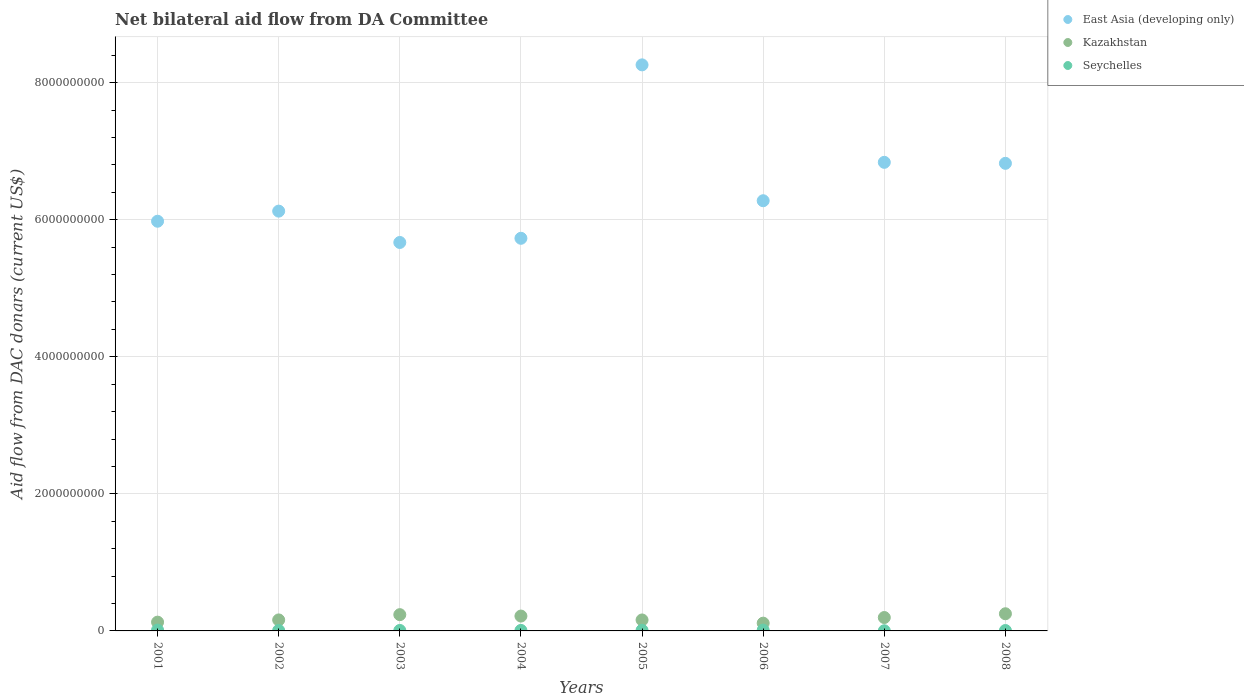How many different coloured dotlines are there?
Your answer should be very brief. 3. Is the number of dotlines equal to the number of legend labels?
Your answer should be compact. Yes. What is the aid flow in in Kazakhstan in 2004?
Offer a terse response. 2.17e+08. Across all years, what is the maximum aid flow in in Kazakhstan?
Offer a very short reply. 2.50e+08. Across all years, what is the minimum aid flow in in Seychelles?
Give a very brief answer. 2.29e+06. What is the total aid flow in in Seychelles in the graph?
Your answer should be compact. 6.18e+07. What is the difference between the aid flow in in Kazakhstan in 2002 and that in 2004?
Provide a short and direct response. -5.61e+07. What is the difference between the aid flow in in Seychelles in 2006 and the aid flow in in Kazakhstan in 2004?
Provide a succinct answer. -2.05e+08. What is the average aid flow in in East Asia (developing only) per year?
Ensure brevity in your answer.  6.46e+09. In the year 2006, what is the difference between the aid flow in in Seychelles and aid flow in in East Asia (developing only)?
Make the answer very short. -6.27e+09. In how many years, is the aid flow in in Kazakhstan greater than 6000000000 US$?
Make the answer very short. 0. What is the ratio of the aid flow in in Seychelles in 2001 to that in 2002?
Offer a very short reply. 1.82. Is the aid flow in in Seychelles in 2007 less than that in 2008?
Ensure brevity in your answer.  Yes. What is the difference between the highest and the second highest aid flow in in Kazakhstan?
Provide a short and direct response. 1.31e+07. What is the difference between the highest and the lowest aid flow in in Seychelles?
Provide a succinct answer. 9.79e+06. In how many years, is the aid flow in in East Asia (developing only) greater than the average aid flow in in East Asia (developing only) taken over all years?
Provide a short and direct response. 3. Is the sum of the aid flow in in Seychelles in 2005 and 2008 greater than the maximum aid flow in in Kazakhstan across all years?
Offer a terse response. No. Is it the case that in every year, the sum of the aid flow in in East Asia (developing only) and aid flow in in Seychelles  is greater than the aid flow in in Kazakhstan?
Your response must be concise. Yes. Does the aid flow in in Kazakhstan monotonically increase over the years?
Ensure brevity in your answer.  No. How many years are there in the graph?
Keep it short and to the point. 8. Are the values on the major ticks of Y-axis written in scientific E-notation?
Provide a short and direct response. No. How are the legend labels stacked?
Provide a short and direct response. Vertical. What is the title of the graph?
Keep it short and to the point. Net bilateral aid flow from DA Committee. Does "Korea (Republic)" appear as one of the legend labels in the graph?
Ensure brevity in your answer.  No. What is the label or title of the Y-axis?
Make the answer very short. Aid flow from DAC donars (current US$). What is the Aid flow from DAC donars (current US$) of East Asia (developing only) in 2001?
Make the answer very short. 5.98e+09. What is the Aid flow from DAC donars (current US$) in Kazakhstan in 2001?
Your answer should be compact. 1.28e+08. What is the Aid flow from DAC donars (current US$) in Seychelles in 2001?
Provide a succinct answer. 1.21e+07. What is the Aid flow from DAC donars (current US$) of East Asia (developing only) in 2002?
Provide a succinct answer. 6.12e+09. What is the Aid flow from DAC donars (current US$) of Kazakhstan in 2002?
Your answer should be compact. 1.61e+08. What is the Aid flow from DAC donars (current US$) of Seychelles in 2002?
Offer a very short reply. 6.64e+06. What is the Aid flow from DAC donars (current US$) of East Asia (developing only) in 2003?
Make the answer very short. 5.67e+09. What is the Aid flow from DAC donars (current US$) of Kazakhstan in 2003?
Ensure brevity in your answer.  2.37e+08. What is the Aid flow from DAC donars (current US$) of Seychelles in 2003?
Your answer should be very brief. 6.68e+06. What is the Aid flow from DAC donars (current US$) of East Asia (developing only) in 2004?
Keep it short and to the point. 5.73e+09. What is the Aid flow from DAC donars (current US$) in Kazakhstan in 2004?
Offer a terse response. 2.17e+08. What is the Aid flow from DAC donars (current US$) of Seychelles in 2004?
Give a very brief answer. 7.43e+06. What is the Aid flow from DAC donars (current US$) in East Asia (developing only) in 2005?
Provide a succinct answer. 8.26e+09. What is the Aid flow from DAC donars (current US$) in Kazakhstan in 2005?
Offer a very short reply. 1.60e+08. What is the Aid flow from DAC donars (current US$) of Seychelles in 2005?
Provide a succinct answer. 9.34e+06. What is the Aid flow from DAC donars (current US$) in East Asia (developing only) in 2006?
Offer a terse response. 6.28e+09. What is the Aid flow from DAC donars (current US$) of Kazakhstan in 2006?
Offer a very short reply. 1.13e+08. What is the Aid flow from DAC donars (current US$) of Seychelles in 2006?
Offer a very short reply. 1.16e+07. What is the Aid flow from DAC donars (current US$) of East Asia (developing only) in 2007?
Your answer should be compact. 6.84e+09. What is the Aid flow from DAC donars (current US$) in Kazakhstan in 2007?
Offer a terse response. 1.95e+08. What is the Aid flow from DAC donars (current US$) in Seychelles in 2007?
Offer a terse response. 2.29e+06. What is the Aid flow from DAC donars (current US$) of East Asia (developing only) in 2008?
Your response must be concise. 6.82e+09. What is the Aid flow from DAC donars (current US$) in Kazakhstan in 2008?
Give a very brief answer. 2.50e+08. What is the Aid flow from DAC donars (current US$) in Seychelles in 2008?
Make the answer very short. 5.77e+06. Across all years, what is the maximum Aid flow from DAC donars (current US$) in East Asia (developing only)?
Keep it short and to the point. 8.26e+09. Across all years, what is the maximum Aid flow from DAC donars (current US$) of Kazakhstan?
Your answer should be compact. 2.50e+08. Across all years, what is the maximum Aid flow from DAC donars (current US$) in Seychelles?
Your answer should be very brief. 1.21e+07. Across all years, what is the minimum Aid flow from DAC donars (current US$) in East Asia (developing only)?
Your answer should be very brief. 5.67e+09. Across all years, what is the minimum Aid flow from DAC donars (current US$) of Kazakhstan?
Give a very brief answer. 1.13e+08. Across all years, what is the minimum Aid flow from DAC donars (current US$) of Seychelles?
Make the answer very short. 2.29e+06. What is the total Aid flow from DAC donars (current US$) of East Asia (developing only) in the graph?
Give a very brief answer. 5.17e+1. What is the total Aid flow from DAC donars (current US$) of Kazakhstan in the graph?
Provide a succinct answer. 1.46e+09. What is the total Aid flow from DAC donars (current US$) of Seychelles in the graph?
Your answer should be compact. 6.18e+07. What is the difference between the Aid flow from DAC donars (current US$) of East Asia (developing only) in 2001 and that in 2002?
Provide a succinct answer. -1.47e+08. What is the difference between the Aid flow from DAC donars (current US$) of Kazakhstan in 2001 and that in 2002?
Your answer should be very brief. -3.24e+07. What is the difference between the Aid flow from DAC donars (current US$) of Seychelles in 2001 and that in 2002?
Provide a short and direct response. 5.44e+06. What is the difference between the Aid flow from DAC donars (current US$) of East Asia (developing only) in 2001 and that in 2003?
Offer a terse response. 3.10e+08. What is the difference between the Aid flow from DAC donars (current US$) in Kazakhstan in 2001 and that in 2003?
Your answer should be compact. -1.09e+08. What is the difference between the Aid flow from DAC donars (current US$) of Seychelles in 2001 and that in 2003?
Provide a short and direct response. 5.40e+06. What is the difference between the Aid flow from DAC donars (current US$) of East Asia (developing only) in 2001 and that in 2004?
Give a very brief answer. 2.49e+08. What is the difference between the Aid flow from DAC donars (current US$) of Kazakhstan in 2001 and that in 2004?
Your answer should be compact. -8.86e+07. What is the difference between the Aid flow from DAC donars (current US$) in Seychelles in 2001 and that in 2004?
Provide a short and direct response. 4.65e+06. What is the difference between the Aid flow from DAC donars (current US$) of East Asia (developing only) in 2001 and that in 2005?
Offer a terse response. -2.28e+09. What is the difference between the Aid flow from DAC donars (current US$) of Kazakhstan in 2001 and that in 2005?
Your response must be concise. -3.19e+07. What is the difference between the Aid flow from DAC donars (current US$) of Seychelles in 2001 and that in 2005?
Your answer should be compact. 2.74e+06. What is the difference between the Aid flow from DAC donars (current US$) in East Asia (developing only) in 2001 and that in 2006?
Provide a succinct answer. -2.99e+08. What is the difference between the Aid flow from DAC donars (current US$) in Kazakhstan in 2001 and that in 2006?
Offer a very short reply. 1.48e+07. What is the difference between the Aid flow from DAC donars (current US$) of Seychelles in 2001 and that in 2006?
Ensure brevity in your answer.  5.30e+05. What is the difference between the Aid flow from DAC donars (current US$) in East Asia (developing only) in 2001 and that in 2007?
Offer a very short reply. -8.59e+08. What is the difference between the Aid flow from DAC donars (current US$) of Kazakhstan in 2001 and that in 2007?
Provide a succinct answer. -6.74e+07. What is the difference between the Aid flow from DAC donars (current US$) of Seychelles in 2001 and that in 2007?
Your response must be concise. 9.79e+06. What is the difference between the Aid flow from DAC donars (current US$) of East Asia (developing only) in 2001 and that in 2008?
Provide a short and direct response. -8.45e+08. What is the difference between the Aid flow from DAC donars (current US$) of Kazakhstan in 2001 and that in 2008?
Ensure brevity in your answer.  -1.22e+08. What is the difference between the Aid flow from DAC donars (current US$) in Seychelles in 2001 and that in 2008?
Provide a short and direct response. 6.31e+06. What is the difference between the Aid flow from DAC donars (current US$) of East Asia (developing only) in 2002 and that in 2003?
Your answer should be compact. 4.57e+08. What is the difference between the Aid flow from DAC donars (current US$) of Kazakhstan in 2002 and that in 2003?
Offer a very short reply. -7.68e+07. What is the difference between the Aid flow from DAC donars (current US$) of East Asia (developing only) in 2002 and that in 2004?
Provide a succinct answer. 3.96e+08. What is the difference between the Aid flow from DAC donars (current US$) in Kazakhstan in 2002 and that in 2004?
Your answer should be compact. -5.61e+07. What is the difference between the Aid flow from DAC donars (current US$) in Seychelles in 2002 and that in 2004?
Ensure brevity in your answer.  -7.90e+05. What is the difference between the Aid flow from DAC donars (current US$) in East Asia (developing only) in 2002 and that in 2005?
Provide a succinct answer. -2.13e+09. What is the difference between the Aid flow from DAC donars (current US$) of Kazakhstan in 2002 and that in 2005?
Provide a succinct answer. 5.00e+05. What is the difference between the Aid flow from DAC donars (current US$) of Seychelles in 2002 and that in 2005?
Keep it short and to the point. -2.70e+06. What is the difference between the Aid flow from DAC donars (current US$) of East Asia (developing only) in 2002 and that in 2006?
Offer a very short reply. -1.52e+08. What is the difference between the Aid flow from DAC donars (current US$) in Kazakhstan in 2002 and that in 2006?
Your response must be concise. 4.72e+07. What is the difference between the Aid flow from DAC donars (current US$) of Seychelles in 2002 and that in 2006?
Ensure brevity in your answer.  -4.91e+06. What is the difference between the Aid flow from DAC donars (current US$) in East Asia (developing only) in 2002 and that in 2007?
Your answer should be very brief. -7.12e+08. What is the difference between the Aid flow from DAC donars (current US$) of Kazakhstan in 2002 and that in 2007?
Make the answer very short. -3.49e+07. What is the difference between the Aid flow from DAC donars (current US$) of Seychelles in 2002 and that in 2007?
Ensure brevity in your answer.  4.35e+06. What is the difference between the Aid flow from DAC donars (current US$) of East Asia (developing only) in 2002 and that in 2008?
Ensure brevity in your answer.  -6.97e+08. What is the difference between the Aid flow from DAC donars (current US$) of Kazakhstan in 2002 and that in 2008?
Keep it short and to the point. -8.99e+07. What is the difference between the Aid flow from DAC donars (current US$) of Seychelles in 2002 and that in 2008?
Your response must be concise. 8.70e+05. What is the difference between the Aid flow from DAC donars (current US$) in East Asia (developing only) in 2003 and that in 2004?
Offer a terse response. -6.10e+07. What is the difference between the Aid flow from DAC donars (current US$) in Kazakhstan in 2003 and that in 2004?
Offer a terse response. 2.07e+07. What is the difference between the Aid flow from DAC donars (current US$) of Seychelles in 2003 and that in 2004?
Offer a very short reply. -7.50e+05. What is the difference between the Aid flow from DAC donars (current US$) of East Asia (developing only) in 2003 and that in 2005?
Your answer should be very brief. -2.59e+09. What is the difference between the Aid flow from DAC donars (current US$) of Kazakhstan in 2003 and that in 2005?
Your answer should be very brief. 7.73e+07. What is the difference between the Aid flow from DAC donars (current US$) of Seychelles in 2003 and that in 2005?
Offer a very short reply. -2.66e+06. What is the difference between the Aid flow from DAC donars (current US$) of East Asia (developing only) in 2003 and that in 2006?
Your answer should be compact. -6.09e+08. What is the difference between the Aid flow from DAC donars (current US$) of Kazakhstan in 2003 and that in 2006?
Make the answer very short. 1.24e+08. What is the difference between the Aid flow from DAC donars (current US$) in Seychelles in 2003 and that in 2006?
Provide a short and direct response. -4.87e+06. What is the difference between the Aid flow from DAC donars (current US$) in East Asia (developing only) in 2003 and that in 2007?
Offer a very short reply. -1.17e+09. What is the difference between the Aid flow from DAC donars (current US$) of Kazakhstan in 2003 and that in 2007?
Your answer should be very brief. 4.19e+07. What is the difference between the Aid flow from DAC donars (current US$) in Seychelles in 2003 and that in 2007?
Offer a very short reply. 4.39e+06. What is the difference between the Aid flow from DAC donars (current US$) of East Asia (developing only) in 2003 and that in 2008?
Provide a short and direct response. -1.15e+09. What is the difference between the Aid flow from DAC donars (current US$) in Kazakhstan in 2003 and that in 2008?
Offer a very short reply. -1.31e+07. What is the difference between the Aid flow from DAC donars (current US$) in Seychelles in 2003 and that in 2008?
Provide a succinct answer. 9.10e+05. What is the difference between the Aid flow from DAC donars (current US$) in East Asia (developing only) in 2004 and that in 2005?
Make the answer very short. -2.53e+09. What is the difference between the Aid flow from DAC donars (current US$) in Kazakhstan in 2004 and that in 2005?
Provide a succinct answer. 5.66e+07. What is the difference between the Aid flow from DAC donars (current US$) in Seychelles in 2004 and that in 2005?
Ensure brevity in your answer.  -1.91e+06. What is the difference between the Aid flow from DAC donars (current US$) in East Asia (developing only) in 2004 and that in 2006?
Provide a succinct answer. -5.48e+08. What is the difference between the Aid flow from DAC donars (current US$) of Kazakhstan in 2004 and that in 2006?
Keep it short and to the point. 1.03e+08. What is the difference between the Aid flow from DAC donars (current US$) in Seychelles in 2004 and that in 2006?
Your response must be concise. -4.12e+06. What is the difference between the Aid flow from DAC donars (current US$) in East Asia (developing only) in 2004 and that in 2007?
Your answer should be compact. -1.11e+09. What is the difference between the Aid flow from DAC donars (current US$) of Kazakhstan in 2004 and that in 2007?
Provide a succinct answer. 2.12e+07. What is the difference between the Aid flow from DAC donars (current US$) of Seychelles in 2004 and that in 2007?
Give a very brief answer. 5.14e+06. What is the difference between the Aid flow from DAC donars (current US$) of East Asia (developing only) in 2004 and that in 2008?
Make the answer very short. -1.09e+09. What is the difference between the Aid flow from DAC donars (current US$) in Kazakhstan in 2004 and that in 2008?
Your answer should be very brief. -3.38e+07. What is the difference between the Aid flow from DAC donars (current US$) in Seychelles in 2004 and that in 2008?
Make the answer very short. 1.66e+06. What is the difference between the Aid flow from DAC donars (current US$) of East Asia (developing only) in 2005 and that in 2006?
Your answer should be very brief. 1.98e+09. What is the difference between the Aid flow from DAC donars (current US$) of Kazakhstan in 2005 and that in 2006?
Provide a succinct answer. 4.67e+07. What is the difference between the Aid flow from DAC donars (current US$) of Seychelles in 2005 and that in 2006?
Provide a short and direct response. -2.21e+06. What is the difference between the Aid flow from DAC donars (current US$) in East Asia (developing only) in 2005 and that in 2007?
Offer a terse response. 1.42e+09. What is the difference between the Aid flow from DAC donars (current US$) of Kazakhstan in 2005 and that in 2007?
Give a very brief answer. -3.54e+07. What is the difference between the Aid flow from DAC donars (current US$) in Seychelles in 2005 and that in 2007?
Provide a succinct answer. 7.05e+06. What is the difference between the Aid flow from DAC donars (current US$) of East Asia (developing only) in 2005 and that in 2008?
Provide a short and direct response. 1.44e+09. What is the difference between the Aid flow from DAC donars (current US$) in Kazakhstan in 2005 and that in 2008?
Make the answer very short. -9.04e+07. What is the difference between the Aid flow from DAC donars (current US$) of Seychelles in 2005 and that in 2008?
Your answer should be compact. 3.57e+06. What is the difference between the Aid flow from DAC donars (current US$) of East Asia (developing only) in 2006 and that in 2007?
Offer a terse response. -5.60e+08. What is the difference between the Aid flow from DAC donars (current US$) in Kazakhstan in 2006 and that in 2007?
Give a very brief answer. -8.22e+07. What is the difference between the Aid flow from DAC donars (current US$) in Seychelles in 2006 and that in 2007?
Provide a short and direct response. 9.26e+06. What is the difference between the Aid flow from DAC donars (current US$) in East Asia (developing only) in 2006 and that in 2008?
Provide a short and direct response. -5.46e+08. What is the difference between the Aid flow from DAC donars (current US$) in Kazakhstan in 2006 and that in 2008?
Offer a very short reply. -1.37e+08. What is the difference between the Aid flow from DAC donars (current US$) of Seychelles in 2006 and that in 2008?
Ensure brevity in your answer.  5.78e+06. What is the difference between the Aid flow from DAC donars (current US$) in East Asia (developing only) in 2007 and that in 2008?
Ensure brevity in your answer.  1.45e+07. What is the difference between the Aid flow from DAC donars (current US$) of Kazakhstan in 2007 and that in 2008?
Provide a short and direct response. -5.50e+07. What is the difference between the Aid flow from DAC donars (current US$) of Seychelles in 2007 and that in 2008?
Make the answer very short. -3.48e+06. What is the difference between the Aid flow from DAC donars (current US$) of East Asia (developing only) in 2001 and the Aid flow from DAC donars (current US$) of Kazakhstan in 2002?
Give a very brief answer. 5.82e+09. What is the difference between the Aid flow from DAC donars (current US$) in East Asia (developing only) in 2001 and the Aid flow from DAC donars (current US$) in Seychelles in 2002?
Keep it short and to the point. 5.97e+09. What is the difference between the Aid flow from DAC donars (current US$) in Kazakhstan in 2001 and the Aid flow from DAC donars (current US$) in Seychelles in 2002?
Your answer should be compact. 1.21e+08. What is the difference between the Aid flow from DAC donars (current US$) in East Asia (developing only) in 2001 and the Aid flow from DAC donars (current US$) in Kazakhstan in 2003?
Offer a very short reply. 5.74e+09. What is the difference between the Aid flow from DAC donars (current US$) of East Asia (developing only) in 2001 and the Aid flow from DAC donars (current US$) of Seychelles in 2003?
Provide a succinct answer. 5.97e+09. What is the difference between the Aid flow from DAC donars (current US$) in Kazakhstan in 2001 and the Aid flow from DAC donars (current US$) in Seychelles in 2003?
Offer a terse response. 1.21e+08. What is the difference between the Aid flow from DAC donars (current US$) in East Asia (developing only) in 2001 and the Aid flow from DAC donars (current US$) in Kazakhstan in 2004?
Your answer should be very brief. 5.76e+09. What is the difference between the Aid flow from DAC donars (current US$) of East Asia (developing only) in 2001 and the Aid flow from DAC donars (current US$) of Seychelles in 2004?
Ensure brevity in your answer.  5.97e+09. What is the difference between the Aid flow from DAC donars (current US$) in Kazakhstan in 2001 and the Aid flow from DAC donars (current US$) in Seychelles in 2004?
Your response must be concise. 1.21e+08. What is the difference between the Aid flow from DAC donars (current US$) in East Asia (developing only) in 2001 and the Aid flow from DAC donars (current US$) in Kazakhstan in 2005?
Offer a terse response. 5.82e+09. What is the difference between the Aid flow from DAC donars (current US$) of East Asia (developing only) in 2001 and the Aid flow from DAC donars (current US$) of Seychelles in 2005?
Make the answer very short. 5.97e+09. What is the difference between the Aid flow from DAC donars (current US$) of Kazakhstan in 2001 and the Aid flow from DAC donars (current US$) of Seychelles in 2005?
Your answer should be compact. 1.19e+08. What is the difference between the Aid flow from DAC donars (current US$) in East Asia (developing only) in 2001 and the Aid flow from DAC donars (current US$) in Kazakhstan in 2006?
Make the answer very short. 5.86e+09. What is the difference between the Aid flow from DAC donars (current US$) of East Asia (developing only) in 2001 and the Aid flow from DAC donars (current US$) of Seychelles in 2006?
Offer a terse response. 5.97e+09. What is the difference between the Aid flow from DAC donars (current US$) in Kazakhstan in 2001 and the Aid flow from DAC donars (current US$) in Seychelles in 2006?
Your answer should be very brief. 1.17e+08. What is the difference between the Aid flow from DAC donars (current US$) in East Asia (developing only) in 2001 and the Aid flow from DAC donars (current US$) in Kazakhstan in 2007?
Make the answer very short. 5.78e+09. What is the difference between the Aid flow from DAC donars (current US$) of East Asia (developing only) in 2001 and the Aid flow from DAC donars (current US$) of Seychelles in 2007?
Your answer should be compact. 5.98e+09. What is the difference between the Aid flow from DAC donars (current US$) in Kazakhstan in 2001 and the Aid flow from DAC donars (current US$) in Seychelles in 2007?
Make the answer very short. 1.26e+08. What is the difference between the Aid flow from DAC donars (current US$) of East Asia (developing only) in 2001 and the Aid flow from DAC donars (current US$) of Kazakhstan in 2008?
Your answer should be very brief. 5.73e+09. What is the difference between the Aid flow from DAC donars (current US$) of East Asia (developing only) in 2001 and the Aid flow from DAC donars (current US$) of Seychelles in 2008?
Keep it short and to the point. 5.97e+09. What is the difference between the Aid flow from DAC donars (current US$) in Kazakhstan in 2001 and the Aid flow from DAC donars (current US$) in Seychelles in 2008?
Offer a terse response. 1.22e+08. What is the difference between the Aid flow from DAC donars (current US$) of East Asia (developing only) in 2002 and the Aid flow from DAC donars (current US$) of Kazakhstan in 2003?
Your response must be concise. 5.89e+09. What is the difference between the Aid flow from DAC donars (current US$) of East Asia (developing only) in 2002 and the Aid flow from DAC donars (current US$) of Seychelles in 2003?
Offer a terse response. 6.12e+09. What is the difference between the Aid flow from DAC donars (current US$) in Kazakhstan in 2002 and the Aid flow from DAC donars (current US$) in Seychelles in 2003?
Offer a terse response. 1.54e+08. What is the difference between the Aid flow from DAC donars (current US$) in East Asia (developing only) in 2002 and the Aid flow from DAC donars (current US$) in Kazakhstan in 2004?
Your response must be concise. 5.91e+09. What is the difference between the Aid flow from DAC donars (current US$) of East Asia (developing only) in 2002 and the Aid flow from DAC donars (current US$) of Seychelles in 2004?
Provide a short and direct response. 6.12e+09. What is the difference between the Aid flow from DAC donars (current US$) in Kazakhstan in 2002 and the Aid flow from DAC donars (current US$) in Seychelles in 2004?
Offer a terse response. 1.53e+08. What is the difference between the Aid flow from DAC donars (current US$) in East Asia (developing only) in 2002 and the Aid flow from DAC donars (current US$) in Kazakhstan in 2005?
Offer a terse response. 5.96e+09. What is the difference between the Aid flow from DAC donars (current US$) in East Asia (developing only) in 2002 and the Aid flow from DAC donars (current US$) in Seychelles in 2005?
Offer a terse response. 6.12e+09. What is the difference between the Aid flow from DAC donars (current US$) of Kazakhstan in 2002 and the Aid flow from DAC donars (current US$) of Seychelles in 2005?
Your response must be concise. 1.51e+08. What is the difference between the Aid flow from DAC donars (current US$) of East Asia (developing only) in 2002 and the Aid flow from DAC donars (current US$) of Kazakhstan in 2006?
Provide a short and direct response. 6.01e+09. What is the difference between the Aid flow from DAC donars (current US$) in East Asia (developing only) in 2002 and the Aid flow from DAC donars (current US$) in Seychelles in 2006?
Your answer should be compact. 6.11e+09. What is the difference between the Aid flow from DAC donars (current US$) of Kazakhstan in 2002 and the Aid flow from DAC donars (current US$) of Seychelles in 2006?
Give a very brief answer. 1.49e+08. What is the difference between the Aid flow from DAC donars (current US$) in East Asia (developing only) in 2002 and the Aid flow from DAC donars (current US$) in Kazakhstan in 2007?
Your answer should be compact. 5.93e+09. What is the difference between the Aid flow from DAC donars (current US$) in East Asia (developing only) in 2002 and the Aid flow from DAC donars (current US$) in Seychelles in 2007?
Provide a short and direct response. 6.12e+09. What is the difference between the Aid flow from DAC donars (current US$) in Kazakhstan in 2002 and the Aid flow from DAC donars (current US$) in Seychelles in 2007?
Ensure brevity in your answer.  1.58e+08. What is the difference between the Aid flow from DAC donars (current US$) of East Asia (developing only) in 2002 and the Aid flow from DAC donars (current US$) of Kazakhstan in 2008?
Your answer should be very brief. 5.87e+09. What is the difference between the Aid flow from DAC donars (current US$) of East Asia (developing only) in 2002 and the Aid flow from DAC donars (current US$) of Seychelles in 2008?
Provide a short and direct response. 6.12e+09. What is the difference between the Aid flow from DAC donars (current US$) of Kazakhstan in 2002 and the Aid flow from DAC donars (current US$) of Seychelles in 2008?
Offer a terse response. 1.55e+08. What is the difference between the Aid flow from DAC donars (current US$) in East Asia (developing only) in 2003 and the Aid flow from DAC donars (current US$) in Kazakhstan in 2004?
Your answer should be compact. 5.45e+09. What is the difference between the Aid flow from DAC donars (current US$) of East Asia (developing only) in 2003 and the Aid flow from DAC donars (current US$) of Seychelles in 2004?
Your answer should be compact. 5.66e+09. What is the difference between the Aid flow from DAC donars (current US$) of Kazakhstan in 2003 and the Aid flow from DAC donars (current US$) of Seychelles in 2004?
Your answer should be compact. 2.30e+08. What is the difference between the Aid flow from DAC donars (current US$) in East Asia (developing only) in 2003 and the Aid flow from DAC donars (current US$) in Kazakhstan in 2005?
Your answer should be compact. 5.51e+09. What is the difference between the Aid flow from DAC donars (current US$) of East Asia (developing only) in 2003 and the Aid flow from DAC donars (current US$) of Seychelles in 2005?
Provide a short and direct response. 5.66e+09. What is the difference between the Aid flow from DAC donars (current US$) in Kazakhstan in 2003 and the Aid flow from DAC donars (current US$) in Seychelles in 2005?
Keep it short and to the point. 2.28e+08. What is the difference between the Aid flow from DAC donars (current US$) in East Asia (developing only) in 2003 and the Aid flow from DAC donars (current US$) in Kazakhstan in 2006?
Provide a short and direct response. 5.55e+09. What is the difference between the Aid flow from DAC donars (current US$) in East Asia (developing only) in 2003 and the Aid flow from DAC donars (current US$) in Seychelles in 2006?
Your response must be concise. 5.66e+09. What is the difference between the Aid flow from DAC donars (current US$) in Kazakhstan in 2003 and the Aid flow from DAC donars (current US$) in Seychelles in 2006?
Offer a very short reply. 2.26e+08. What is the difference between the Aid flow from DAC donars (current US$) in East Asia (developing only) in 2003 and the Aid flow from DAC donars (current US$) in Kazakhstan in 2007?
Your answer should be compact. 5.47e+09. What is the difference between the Aid flow from DAC donars (current US$) in East Asia (developing only) in 2003 and the Aid flow from DAC donars (current US$) in Seychelles in 2007?
Your answer should be very brief. 5.67e+09. What is the difference between the Aid flow from DAC donars (current US$) of Kazakhstan in 2003 and the Aid flow from DAC donars (current US$) of Seychelles in 2007?
Provide a short and direct response. 2.35e+08. What is the difference between the Aid flow from DAC donars (current US$) in East Asia (developing only) in 2003 and the Aid flow from DAC donars (current US$) in Kazakhstan in 2008?
Ensure brevity in your answer.  5.42e+09. What is the difference between the Aid flow from DAC donars (current US$) in East Asia (developing only) in 2003 and the Aid flow from DAC donars (current US$) in Seychelles in 2008?
Offer a terse response. 5.66e+09. What is the difference between the Aid flow from DAC donars (current US$) in Kazakhstan in 2003 and the Aid flow from DAC donars (current US$) in Seychelles in 2008?
Keep it short and to the point. 2.32e+08. What is the difference between the Aid flow from DAC donars (current US$) in East Asia (developing only) in 2004 and the Aid flow from DAC donars (current US$) in Kazakhstan in 2005?
Offer a terse response. 5.57e+09. What is the difference between the Aid flow from DAC donars (current US$) in East Asia (developing only) in 2004 and the Aid flow from DAC donars (current US$) in Seychelles in 2005?
Your answer should be compact. 5.72e+09. What is the difference between the Aid flow from DAC donars (current US$) in Kazakhstan in 2004 and the Aid flow from DAC donars (current US$) in Seychelles in 2005?
Give a very brief answer. 2.07e+08. What is the difference between the Aid flow from DAC donars (current US$) in East Asia (developing only) in 2004 and the Aid flow from DAC donars (current US$) in Kazakhstan in 2006?
Offer a terse response. 5.62e+09. What is the difference between the Aid flow from DAC donars (current US$) of East Asia (developing only) in 2004 and the Aid flow from DAC donars (current US$) of Seychelles in 2006?
Your answer should be compact. 5.72e+09. What is the difference between the Aid flow from DAC donars (current US$) of Kazakhstan in 2004 and the Aid flow from DAC donars (current US$) of Seychelles in 2006?
Your answer should be compact. 2.05e+08. What is the difference between the Aid flow from DAC donars (current US$) of East Asia (developing only) in 2004 and the Aid flow from DAC donars (current US$) of Kazakhstan in 2007?
Your answer should be compact. 5.53e+09. What is the difference between the Aid flow from DAC donars (current US$) in East Asia (developing only) in 2004 and the Aid flow from DAC donars (current US$) in Seychelles in 2007?
Ensure brevity in your answer.  5.73e+09. What is the difference between the Aid flow from DAC donars (current US$) of Kazakhstan in 2004 and the Aid flow from DAC donars (current US$) of Seychelles in 2007?
Your answer should be very brief. 2.14e+08. What is the difference between the Aid flow from DAC donars (current US$) of East Asia (developing only) in 2004 and the Aid flow from DAC donars (current US$) of Kazakhstan in 2008?
Ensure brevity in your answer.  5.48e+09. What is the difference between the Aid flow from DAC donars (current US$) of East Asia (developing only) in 2004 and the Aid flow from DAC donars (current US$) of Seychelles in 2008?
Your answer should be very brief. 5.72e+09. What is the difference between the Aid flow from DAC donars (current US$) of Kazakhstan in 2004 and the Aid flow from DAC donars (current US$) of Seychelles in 2008?
Keep it short and to the point. 2.11e+08. What is the difference between the Aid flow from DAC donars (current US$) in East Asia (developing only) in 2005 and the Aid flow from DAC donars (current US$) in Kazakhstan in 2006?
Provide a succinct answer. 8.15e+09. What is the difference between the Aid flow from DAC donars (current US$) in East Asia (developing only) in 2005 and the Aid flow from DAC donars (current US$) in Seychelles in 2006?
Provide a short and direct response. 8.25e+09. What is the difference between the Aid flow from DAC donars (current US$) in Kazakhstan in 2005 and the Aid flow from DAC donars (current US$) in Seychelles in 2006?
Your answer should be compact. 1.48e+08. What is the difference between the Aid flow from DAC donars (current US$) in East Asia (developing only) in 2005 and the Aid flow from DAC donars (current US$) in Kazakhstan in 2007?
Keep it short and to the point. 8.06e+09. What is the difference between the Aid flow from DAC donars (current US$) in East Asia (developing only) in 2005 and the Aid flow from DAC donars (current US$) in Seychelles in 2007?
Offer a terse response. 8.26e+09. What is the difference between the Aid flow from DAC donars (current US$) of Kazakhstan in 2005 and the Aid flow from DAC donars (current US$) of Seychelles in 2007?
Offer a terse response. 1.58e+08. What is the difference between the Aid flow from DAC donars (current US$) in East Asia (developing only) in 2005 and the Aid flow from DAC donars (current US$) in Kazakhstan in 2008?
Provide a succinct answer. 8.01e+09. What is the difference between the Aid flow from DAC donars (current US$) in East Asia (developing only) in 2005 and the Aid flow from DAC donars (current US$) in Seychelles in 2008?
Make the answer very short. 8.25e+09. What is the difference between the Aid flow from DAC donars (current US$) of Kazakhstan in 2005 and the Aid flow from DAC donars (current US$) of Seychelles in 2008?
Provide a short and direct response. 1.54e+08. What is the difference between the Aid flow from DAC donars (current US$) in East Asia (developing only) in 2006 and the Aid flow from DAC donars (current US$) in Kazakhstan in 2007?
Keep it short and to the point. 6.08e+09. What is the difference between the Aid flow from DAC donars (current US$) in East Asia (developing only) in 2006 and the Aid flow from DAC donars (current US$) in Seychelles in 2007?
Your answer should be compact. 6.27e+09. What is the difference between the Aid flow from DAC donars (current US$) of Kazakhstan in 2006 and the Aid flow from DAC donars (current US$) of Seychelles in 2007?
Provide a short and direct response. 1.11e+08. What is the difference between the Aid flow from DAC donars (current US$) of East Asia (developing only) in 2006 and the Aid flow from DAC donars (current US$) of Kazakhstan in 2008?
Your response must be concise. 6.03e+09. What is the difference between the Aid flow from DAC donars (current US$) in East Asia (developing only) in 2006 and the Aid flow from DAC donars (current US$) in Seychelles in 2008?
Offer a very short reply. 6.27e+09. What is the difference between the Aid flow from DAC donars (current US$) in Kazakhstan in 2006 and the Aid flow from DAC donars (current US$) in Seychelles in 2008?
Provide a succinct answer. 1.08e+08. What is the difference between the Aid flow from DAC donars (current US$) in East Asia (developing only) in 2007 and the Aid flow from DAC donars (current US$) in Kazakhstan in 2008?
Offer a terse response. 6.59e+09. What is the difference between the Aid flow from DAC donars (current US$) in East Asia (developing only) in 2007 and the Aid flow from DAC donars (current US$) in Seychelles in 2008?
Make the answer very short. 6.83e+09. What is the difference between the Aid flow from DAC donars (current US$) of Kazakhstan in 2007 and the Aid flow from DAC donars (current US$) of Seychelles in 2008?
Provide a succinct answer. 1.90e+08. What is the average Aid flow from DAC donars (current US$) of East Asia (developing only) per year?
Your answer should be compact. 6.46e+09. What is the average Aid flow from DAC donars (current US$) in Kazakhstan per year?
Provide a succinct answer. 1.83e+08. What is the average Aid flow from DAC donars (current US$) in Seychelles per year?
Provide a succinct answer. 7.72e+06. In the year 2001, what is the difference between the Aid flow from DAC donars (current US$) in East Asia (developing only) and Aid flow from DAC donars (current US$) in Kazakhstan?
Keep it short and to the point. 5.85e+09. In the year 2001, what is the difference between the Aid flow from DAC donars (current US$) of East Asia (developing only) and Aid flow from DAC donars (current US$) of Seychelles?
Provide a succinct answer. 5.97e+09. In the year 2001, what is the difference between the Aid flow from DAC donars (current US$) of Kazakhstan and Aid flow from DAC donars (current US$) of Seychelles?
Your answer should be very brief. 1.16e+08. In the year 2002, what is the difference between the Aid flow from DAC donars (current US$) of East Asia (developing only) and Aid flow from DAC donars (current US$) of Kazakhstan?
Your answer should be very brief. 5.96e+09. In the year 2002, what is the difference between the Aid flow from DAC donars (current US$) in East Asia (developing only) and Aid flow from DAC donars (current US$) in Seychelles?
Provide a short and direct response. 6.12e+09. In the year 2002, what is the difference between the Aid flow from DAC donars (current US$) in Kazakhstan and Aid flow from DAC donars (current US$) in Seychelles?
Give a very brief answer. 1.54e+08. In the year 2003, what is the difference between the Aid flow from DAC donars (current US$) of East Asia (developing only) and Aid flow from DAC donars (current US$) of Kazakhstan?
Provide a short and direct response. 5.43e+09. In the year 2003, what is the difference between the Aid flow from DAC donars (current US$) in East Asia (developing only) and Aid flow from DAC donars (current US$) in Seychelles?
Ensure brevity in your answer.  5.66e+09. In the year 2003, what is the difference between the Aid flow from DAC donars (current US$) of Kazakhstan and Aid flow from DAC donars (current US$) of Seychelles?
Your answer should be compact. 2.31e+08. In the year 2004, what is the difference between the Aid flow from DAC donars (current US$) in East Asia (developing only) and Aid flow from DAC donars (current US$) in Kazakhstan?
Keep it short and to the point. 5.51e+09. In the year 2004, what is the difference between the Aid flow from DAC donars (current US$) in East Asia (developing only) and Aid flow from DAC donars (current US$) in Seychelles?
Provide a short and direct response. 5.72e+09. In the year 2004, what is the difference between the Aid flow from DAC donars (current US$) of Kazakhstan and Aid flow from DAC donars (current US$) of Seychelles?
Offer a very short reply. 2.09e+08. In the year 2005, what is the difference between the Aid flow from DAC donars (current US$) in East Asia (developing only) and Aid flow from DAC donars (current US$) in Kazakhstan?
Provide a succinct answer. 8.10e+09. In the year 2005, what is the difference between the Aid flow from DAC donars (current US$) in East Asia (developing only) and Aid flow from DAC donars (current US$) in Seychelles?
Give a very brief answer. 8.25e+09. In the year 2005, what is the difference between the Aid flow from DAC donars (current US$) of Kazakhstan and Aid flow from DAC donars (current US$) of Seychelles?
Offer a terse response. 1.51e+08. In the year 2006, what is the difference between the Aid flow from DAC donars (current US$) in East Asia (developing only) and Aid flow from DAC donars (current US$) in Kazakhstan?
Give a very brief answer. 6.16e+09. In the year 2006, what is the difference between the Aid flow from DAC donars (current US$) of East Asia (developing only) and Aid flow from DAC donars (current US$) of Seychelles?
Provide a short and direct response. 6.27e+09. In the year 2006, what is the difference between the Aid flow from DAC donars (current US$) in Kazakhstan and Aid flow from DAC donars (current US$) in Seychelles?
Your response must be concise. 1.02e+08. In the year 2007, what is the difference between the Aid flow from DAC donars (current US$) of East Asia (developing only) and Aid flow from DAC donars (current US$) of Kazakhstan?
Ensure brevity in your answer.  6.64e+09. In the year 2007, what is the difference between the Aid flow from DAC donars (current US$) of East Asia (developing only) and Aid flow from DAC donars (current US$) of Seychelles?
Offer a terse response. 6.83e+09. In the year 2007, what is the difference between the Aid flow from DAC donars (current US$) of Kazakhstan and Aid flow from DAC donars (current US$) of Seychelles?
Keep it short and to the point. 1.93e+08. In the year 2008, what is the difference between the Aid flow from DAC donars (current US$) of East Asia (developing only) and Aid flow from DAC donars (current US$) of Kazakhstan?
Offer a very short reply. 6.57e+09. In the year 2008, what is the difference between the Aid flow from DAC donars (current US$) in East Asia (developing only) and Aid flow from DAC donars (current US$) in Seychelles?
Give a very brief answer. 6.82e+09. In the year 2008, what is the difference between the Aid flow from DAC donars (current US$) of Kazakhstan and Aid flow from DAC donars (current US$) of Seychelles?
Offer a very short reply. 2.45e+08. What is the ratio of the Aid flow from DAC donars (current US$) in East Asia (developing only) in 2001 to that in 2002?
Your answer should be very brief. 0.98. What is the ratio of the Aid flow from DAC donars (current US$) in Kazakhstan in 2001 to that in 2002?
Ensure brevity in your answer.  0.8. What is the ratio of the Aid flow from DAC donars (current US$) in Seychelles in 2001 to that in 2002?
Make the answer very short. 1.82. What is the ratio of the Aid flow from DAC donars (current US$) in East Asia (developing only) in 2001 to that in 2003?
Keep it short and to the point. 1.05. What is the ratio of the Aid flow from DAC donars (current US$) of Kazakhstan in 2001 to that in 2003?
Offer a very short reply. 0.54. What is the ratio of the Aid flow from DAC donars (current US$) of Seychelles in 2001 to that in 2003?
Offer a very short reply. 1.81. What is the ratio of the Aid flow from DAC donars (current US$) in East Asia (developing only) in 2001 to that in 2004?
Your answer should be very brief. 1.04. What is the ratio of the Aid flow from DAC donars (current US$) of Kazakhstan in 2001 to that in 2004?
Make the answer very short. 0.59. What is the ratio of the Aid flow from DAC donars (current US$) in Seychelles in 2001 to that in 2004?
Ensure brevity in your answer.  1.63. What is the ratio of the Aid flow from DAC donars (current US$) of East Asia (developing only) in 2001 to that in 2005?
Your answer should be very brief. 0.72. What is the ratio of the Aid flow from DAC donars (current US$) of Kazakhstan in 2001 to that in 2005?
Provide a short and direct response. 0.8. What is the ratio of the Aid flow from DAC donars (current US$) of Seychelles in 2001 to that in 2005?
Keep it short and to the point. 1.29. What is the ratio of the Aid flow from DAC donars (current US$) of East Asia (developing only) in 2001 to that in 2006?
Make the answer very short. 0.95. What is the ratio of the Aid flow from DAC donars (current US$) of Kazakhstan in 2001 to that in 2006?
Provide a succinct answer. 1.13. What is the ratio of the Aid flow from DAC donars (current US$) of Seychelles in 2001 to that in 2006?
Provide a succinct answer. 1.05. What is the ratio of the Aid flow from DAC donars (current US$) in East Asia (developing only) in 2001 to that in 2007?
Your response must be concise. 0.87. What is the ratio of the Aid flow from DAC donars (current US$) in Kazakhstan in 2001 to that in 2007?
Offer a terse response. 0.66. What is the ratio of the Aid flow from DAC donars (current US$) of Seychelles in 2001 to that in 2007?
Your answer should be compact. 5.28. What is the ratio of the Aid flow from DAC donars (current US$) in East Asia (developing only) in 2001 to that in 2008?
Offer a terse response. 0.88. What is the ratio of the Aid flow from DAC donars (current US$) in Kazakhstan in 2001 to that in 2008?
Make the answer very short. 0.51. What is the ratio of the Aid flow from DAC donars (current US$) of Seychelles in 2001 to that in 2008?
Make the answer very short. 2.09. What is the ratio of the Aid flow from DAC donars (current US$) of East Asia (developing only) in 2002 to that in 2003?
Make the answer very short. 1.08. What is the ratio of the Aid flow from DAC donars (current US$) of Kazakhstan in 2002 to that in 2003?
Your answer should be very brief. 0.68. What is the ratio of the Aid flow from DAC donars (current US$) in Seychelles in 2002 to that in 2003?
Ensure brevity in your answer.  0.99. What is the ratio of the Aid flow from DAC donars (current US$) of East Asia (developing only) in 2002 to that in 2004?
Give a very brief answer. 1.07. What is the ratio of the Aid flow from DAC donars (current US$) in Kazakhstan in 2002 to that in 2004?
Your answer should be compact. 0.74. What is the ratio of the Aid flow from DAC donars (current US$) in Seychelles in 2002 to that in 2004?
Offer a terse response. 0.89. What is the ratio of the Aid flow from DAC donars (current US$) of East Asia (developing only) in 2002 to that in 2005?
Your answer should be compact. 0.74. What is the ratio of the Aid flow from DAC donars (current US$) in Kazakhstan in 2002 to that in 2005?
Keep it short and to the point. 1. What is the ratio of the Aid flow from DAC donars (current US$) of Seychelles in 2002 to that in 2005?
Provide a succinct answer. 0.71. What is the ratio of the Aid flow from DAC donars (current US$) in East Asia (developing only) in 2002 to that in 2006?
Offer a very short reply. 0.98. What is the ratio of the Aid flow from DAC donars (current US$) in Kazakhstan in 2002 to that in 2006?
Your response must be concise. 1.42. What is the ratio of the Aid flow from DAC donars (current US$) of Seychelles in 2002 to that in 2006?
Give a very brief answer. 0.57. What is the ratio of the Aid flow from DAC donars (current US$) in East Asia (developing only) in 2002 to that in 2007?
Offer a terse response. 0.9. What is the ratio of the Aid flow from DAC donars (current US$) of Kazakhstan in 2002 to that in 2007?
Your answer should be very brief. 0.82. What is the ratio of the Aid flow from DAC donars (current US$) in Seychelles in 2002 to that in 2007?
Offer a terse response. 2.9. What is the ratio of the Aid flow from DAC donars (current US$) of East Asia (developing only) in 2002 to that in 2008?
Make the answer very short. 0.9. What is the ratio of the Aid flow from DAC donars (current US$) in Kazakhstan in 2002 to that in 2008?
Your answer should be very brief. 0.64. What is the ratio of the Aid flow from DAC donars (current US$) of Seychelles in 2002 to that in 2008?
Offer a terse response. 1.15. What is the ratio of the Aid flow from DAC donars (current US$) of East Asia (developing only) in 2003 to that in 2004?
Give a very brief answer. 0.99. What is the ratio of the Aid flow from DAC donars (current US$) of Kazakhstan in 2003 to that in 2004?
Offer a terse response. 1.1. What is the ratio of the Aid flow from DAC donars (current US$) of Seychelles in 2003 to that in 2004?
Your answer should be compact. 0.9. What is the ratio of the Aid flow from DAC donars (current US$) of East Asia (developing only) in 2003 to that in 2005?
Offer a terse response. 0.69. What is the ratio of the Aid flow from DAC donars (current US$) of Kazakhstan in 2003 to that in 2005?
Offer a terse response. 1.48. What is the ratio of the Aid flow from DAC donars (current US$) of Seychelles in 2003 to that in 2005?
Ensure brevity in your answer.  0.72. What is the ratio of the Aid flow from DAC donars (current US$) in East Asia (developing only) in 2003 to that in 2006?
Give a very brief answer. 0.9. What is the ratio of the Aid flow from DAC donars (current US$) in Kazakhstan in 2003 to that in 2006?
Your response must be concise. 2.09. What is the ratio of the Aid flow from DAC donars (current US$) of Seychelles in 2003 to that in 2006?
Provide a short and direct response. 0.58. What is the ratio of the Aid flow from DAC donars (current US$) of East Asia (developing only) in 2003 to that in 2007?
Your response must be concise. 0.83. What is the ratio of the Aid flow from DAC donars (current US$) in Kazakhstan in 2003 to that in 2007?
Offer a very short reply. 1.21. What is the ratio of the Aid flow from DAC donars (current US$) in Seychelles in 2003 to that in 2007?
Your answer should be compact. 2.92. What is the ratio of the Aid flow from DAC donars (current US$) in East Asia (developing only) in 2003 to that in 2008?
Provide a short and direct response. 0.83. What is the ratio of the Aid flow from DAC donars (current US$) of Kazakhstan in 2003 to that in 2008?
Provide a short and direct response. 0.95. What is the ratio of the Aid flow from DAC donars (current US$) of Seychelles in 2003 to that in 2008?
Offer a terse response. 1.16. What is the ratio of the Aid flow from DAC donars (current US$) of East Asia (developing only) in 2004 to that in 2005?
Offer a very short reply. 0.69. What is the ratio of the Aid flow from DAC donars (current US$) of Kazakhstan in 2004 to that in 2005?
Ensure brevity in your answer.  1.35. What is the ratio of the Aid flow from DAC donars (current US$) of Seychelles in 2004 to that in 2005?
Keep it short and to the point. 0.8. What is the ratio of the Aid flow from DAC donars (current US$) of East Asia (developing only) in 2004 to that in 2006?
Offer a terse response. 0.91. What is the ratio of the Aid flow from DAC donars (current US$) of Kazakhstan in 2004 to that in 2006?
Your response must be concise. 1.91. What is the ratio of the Aid flow from DAC donars (current US$) in Seychelles in 2004 to that in 2006?
Offer a very short reply. 0.64. What is the ratio of the Aid flow from DAC donars (current US$) of East Asia (developing only) in 2004 to that in 2007?
Offer a terse response. 0.84. What is the ratio of the Aid flow from DAC donars (current US$) of Kazakhstan in 2004 to that in 2007?
Keep it short and to the point. 1.11. What is the ratio of the Aid flow from DAC donars (current US$) of Seychelles in 2004 to that in 2007?
Offer a very short reply. 3.24. What is the ratio of the Aid flow from DAC donars (current US$) of East Asia (developing only) in 2004 to that in 2008?
Keep it short and to the point. 0.84. What is the ratio of the Aid flow from DAC donars (current US$) of Kazakhstan in 2004 to that in 2008?
Your answer should be compact. 0.87. What is the ratio of the Aid flow from DAC donars (current US$) in Seychelles in 2004 to that in 2008?
Give a very brief answer. 1.29. What is the ratio of the Aid flow from DAC donars (current US$) of East Asia (developing only) in 2005 to that in 2006?
Give a very brief answer. 1.32. What is the ratio of the Aid flow from DAC donars (current US$) in Kazakhstan in 2005 to that in 2006?
Provide a short and direct response. 1.41. What is the ratio of the Aid flow from DAC donars (current US$) of Seychelles in 2005 to that in 2006?
Provide a succinct answer. 0.81. What is the ratio of the Aid flow from DAC donars (current US$) in East Asia (developing only) in 2005 to that in 2007?
Your answer should be compact. 1.21. What is the ratio of the Aid flow from DAC donars (current US$) of Kazakhstan in 2005 to that in 2007?
Keep it short and to the point. 0.82. What is the ratio of the Aid flow from DAC donars (current US$) of Seychelles in 2005 to that in 2007?
Provide a short and direct response. 4.08. What is the ratio of the Aid flow from DAC donars (current US$) in East Asia (developing only) in 2005 to that in 2008?
Give a very brief answer. 1.21. What is the ratio of the Aid flow from DAC donars (current US$) in Kazakhstan in 2005 to that in 2008?
Offer a terse response. 0.64. What is the ratio of the Aid flow from DAC donars (current US$) in Seychelles in 2005 to that in 2008?
Your answer should be compact. 1.62. What is the ratio of the Aid flow from DAC donars (current US$) in East Asia (developing only) in 2006 to that in 2007?
Make the answer very short. 0.92. What is the ratio of the Aid flow from DAC donars (current US$) in Kazakhstan in 2006 to that in 2007?
Provide a short and direct response. 0.58. What is the ratio of the Aid flow from DAC donars (current US$) in Seychelles in 2006 to that in 2007?
Provide a succinct answer. 5.04. What is the ratio of the Aid flow from DAC donars (current US$) in Kazakhstan in 2006 to that in 2008?
Ensure brevity in your answer.  0.45. What is the ratio of the Aid flow from DAC donars (current US$) in Seychelles in 2006 to that in 2008?
Give a very brief answer. 2. What is the ratio of the Aid flow from DAC donars (current US$) in East Asia (developing only) in 2007 to that in 2008?
Offer a terse response. 1. What is the ratio of the Aid flow from DAC donars (current US$) in Kazakhstan in 2007 to that in 2008?
Make the answer very short. 0.78. What is the ratio of the Aid flow from DAC donars (current US$) in Seychelles in 2007 to that in 2008?
Make the answer very short. 0.4. What is the difference between the highest and the second highest Aid flow from DAC donars (current US$) in East Asia (developing only)?
Provide a succinct answer. 1.42e+09. What is the difference between the highest and the second highest Aid flow from DAC donars (current US$) of Kazakhstan?
Keep it short and to the point. 1.31e+07. What is the difference between the highest and the second highest Aid flow from DAC donars (current US$) of Seychelles?
Ensure brevity in your answer.  5.30e+05. What is the difference between the highest and the lowest Aid flow from DAC donars (current US$) of East Asia (developing only)?
Provide a short and direct response. 2.59e+09. What is the difference between the highest and the lowest Aid flow from DAC donars (current US$) in Kazakhstan?
Give a very brief answer. 1.37e+08. What is the difference between the highest and the lowest Aid flow from DAC donars (current US$) of Seychelles?
Give a very brief answer. 9.79e+06. 